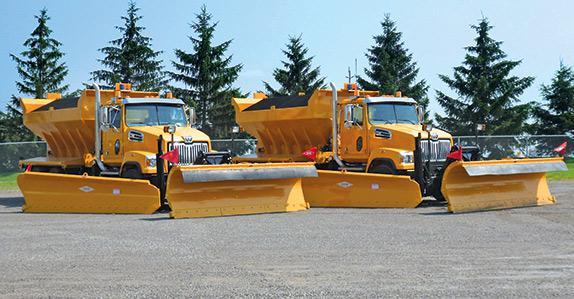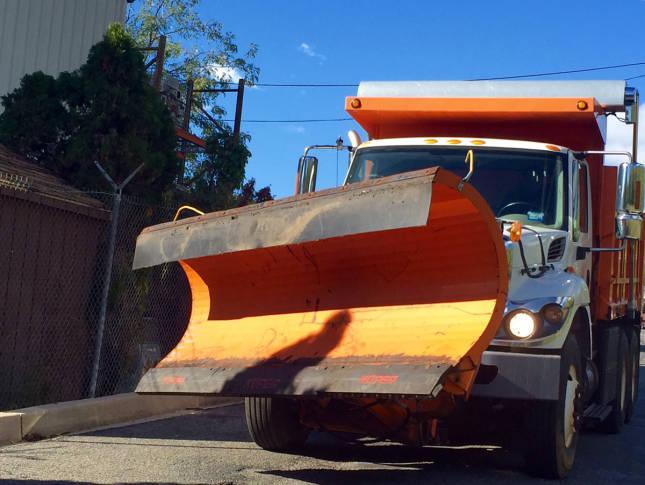The first image is the image on the left, the second image is the image on the right. For the images shown, is this caption "An image shows multiple trucks with golden-yellow cabs and beds parked in a dry paved area." true? Answer yes or no. Yes. The first image is the image on the left, the second image is the image on the right. Assess this claim about the two images: "There are two bulldozers both facing left.". Correct or not? Answer yes or no. No. 